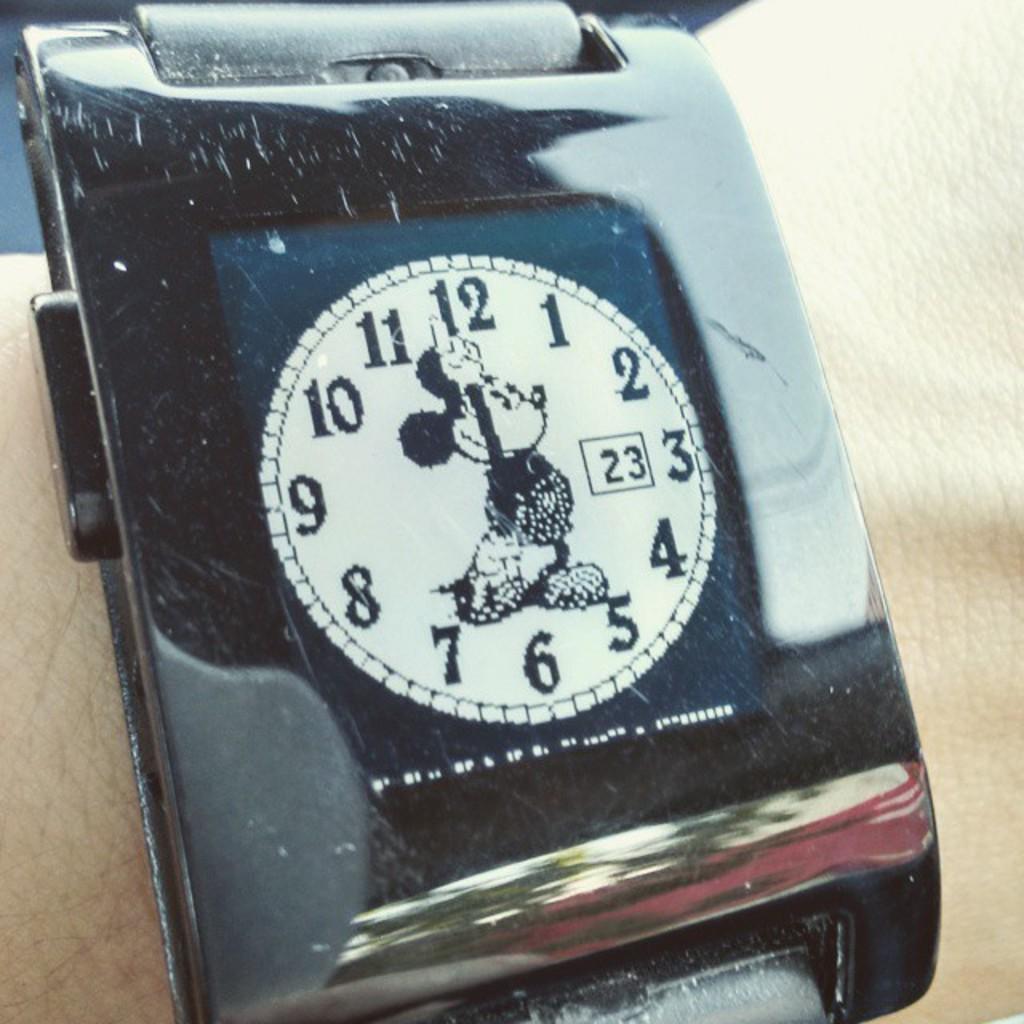What is the number in the box?
Provide a short and direct response. 23. What time does it say it is?
Offer a very short reply. 6:58. 